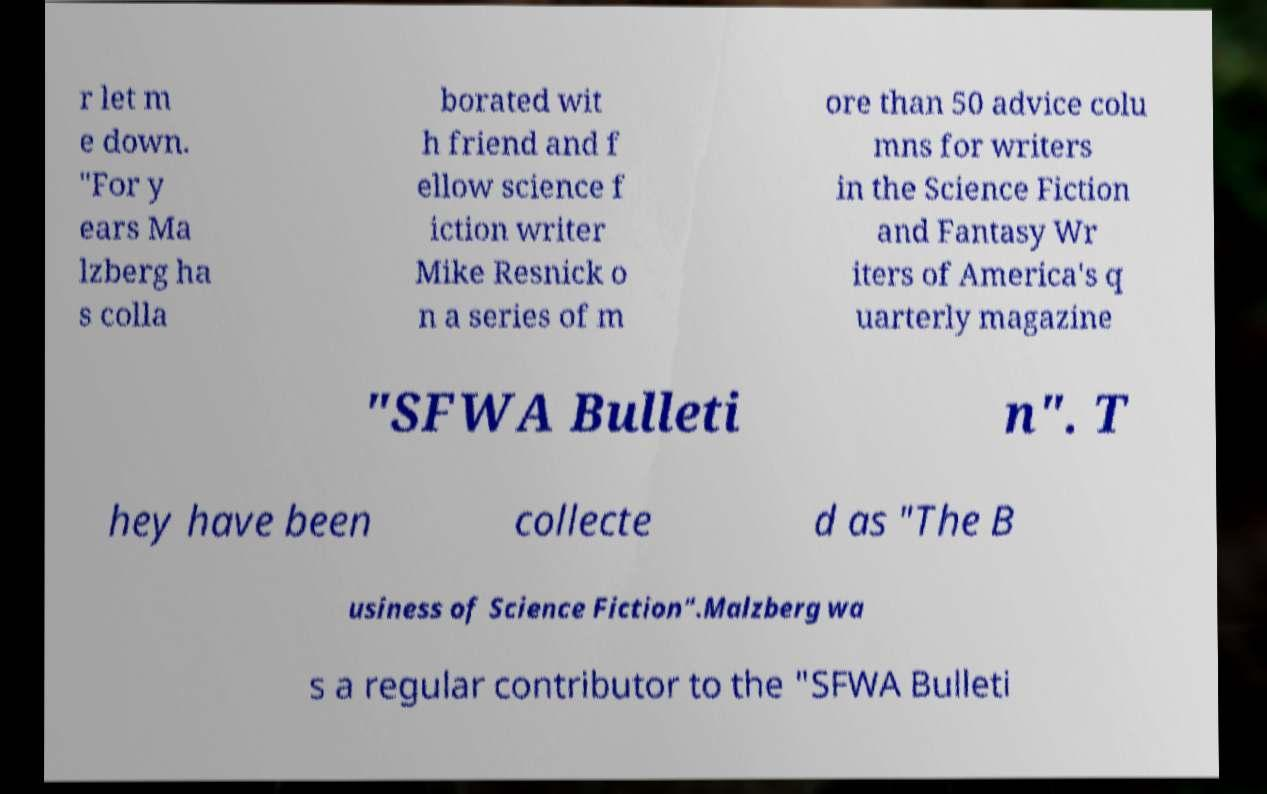Could you extract and type out the text from this image? r let m e down. "For y ears Ma lzberg ha s colla borated wit h friend and f ellow science f iction writer Mike Resnick o n a series of m ore than 50 advice colu mns for writers in the Science Fiction and Fantasy Wr iters of America's q uarterly magazine "SFWA Bulleti n". T hey have been collecte d as "The B usiness of Science Fiction".Malzberg wa s a regular contributor to the "SFWA Bulleti 